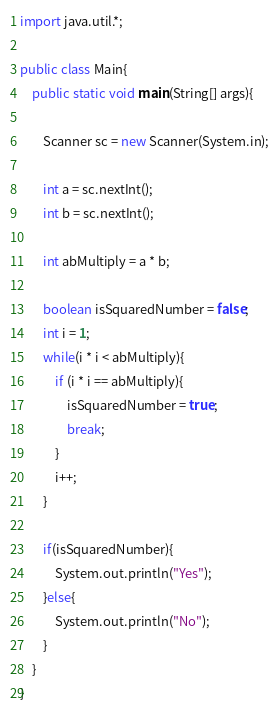<code> <loc_0><loc_0><loc_500><loc_500><_Java_>import java.util.*;

public class Main{
	public static void main(String[] args){
    	
     	Scanner sc = new Scanner(System.in);
      	
      	int a = sc.nextInt();
      	int b = sc.nextInt();
      
      	int abMultiply = a * b;
      
      	boolean isSquaredNumber = false;
      	int i = 1;
      	while(i * i < abMultiply){
        	if (i * i == abMultiply){
            	isSquaredNumber = true;
              	break;
            }
          	i++;
        }
      	
      	if(isSquaredNumber){
        	System.out.println("Yes");
        }else{
        	System.out.println("No");
        }
    }
}</code> 